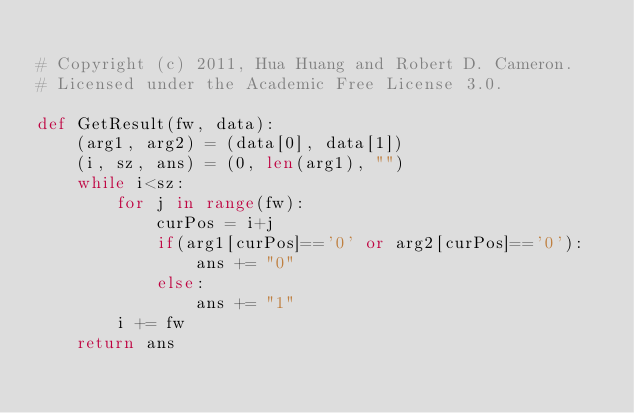<code> <loc_0><loc_0><loc_500><loc_500><_Python_>
# Copyright (c) 2011, Hua Huang and Robert D. Cameron.
# Licensed under the Academic Free License 3.0. 

def GetResult(fw, data):
    (arg1, arg2) = (data[0], data[1])
    (i, sz, ans) = (0, len(arg1), "")
    while i<sz:
        for j in range(fw):
            curPos = i+j
            if(arg1[curPos]=='0' or arg2[curPos]=='0'):
                ans += "0"
            else:
                ans += "1"
        i += fw
    return ans
</code> 